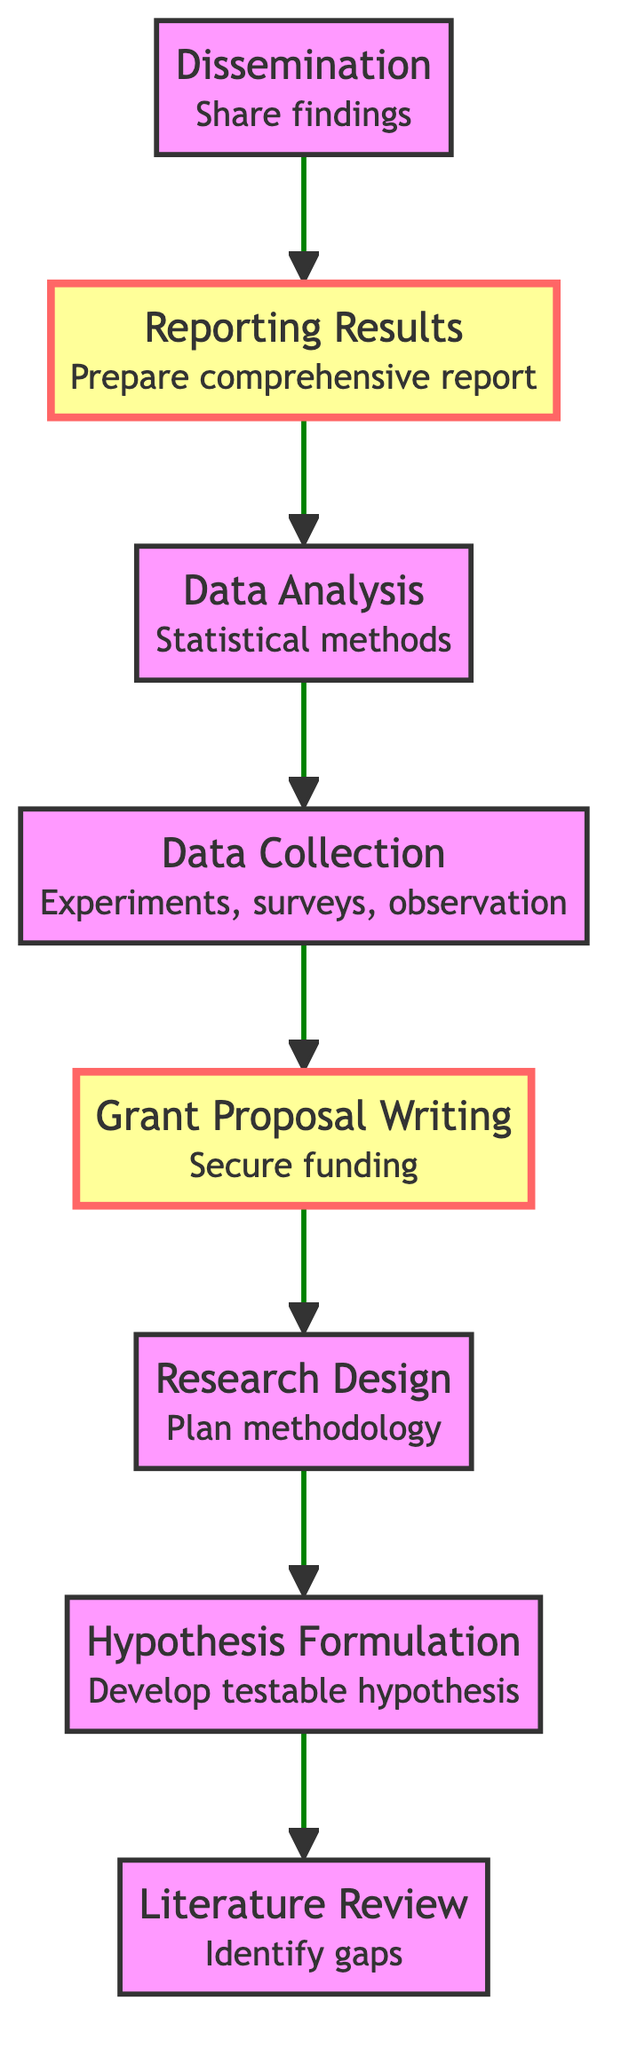What is the first step in the research workflow? The first step in the diagram is "Literature Review". It is the starting point of the research process, identifying gaps to formulate the hypothesis.
Answer: Literature Review How many total steps are there in the research workflow? By counting the elements in the diagram, there are a total of eight steps involved from the "Literature Review" to "Dissemination".
Answer: Eight What follows "Data Collection" in the workflow? The next step after "Data Collection" is "Data Analysis". This indicates a sequential relationship where data collected is subjected to analysis.
Answer: Data Analysis Which step is emphasized in the diagram? The emphasized steps in the diagram are "Grant Proposal Writing" and "Reporting Results", which are highlighted with a different fill color and stroke width.
Answer: Grant Proposal Writing, Reporting Results What is the outcome of the "Data Analysis"? The outcome indicated by "Data Analysis" leads to "Reporting Results", meaning the analysis results culminate in comprehensive findings being reported.
Answer: Reporting Results What is the relationship between "Hypothesis Formulation" and "Literature Review"? "Hypothesis Formulation" directly follows "Literature Review", meaning the hypothesis is developed based on the knowledge gained from reviewing literature.
Answer: Directly follows Which step is the last in the workflow? The last step in the workflow is "Dissemination", which signifies that after completing the research, findings are shared with the broader community.
Answer: Dissemination How many elements describe the data collection process? The element "Data Collection" explicitly describes collecting data through methods such as experiments, surveys, or observations, indicating it has one description.
Answer: One What does the diagram suggest about the importance of grant proposals? The diagram emphasizes "Grant Proposal Writing" as a critical step to secure funding, which suggests it plays a significant role in successfully conducting research.
Answer: Essential step 